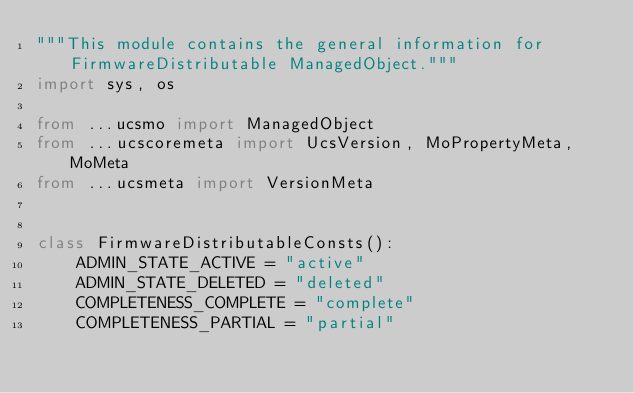<code> <loc_0><loc_0><loc_500><loc_500><_Python_>"""This module contains the general information for FirmwareDistributable ManagedObject."""
import sys, os

from ...ucsmo import ManagedObject
from ...ucscoremeta import UcsVersion, MoPropertyMeta, MoMeta
from ...ucsmeta import VersionMeta


class FirmwareDistributableConsts():
    ADMIN_STATE_ACTIVE = "active"
    ADMIN_STATE_DELETED = "deleted"
    COMPLETENESS_COMPLETE = "complete"
    COMPLETENESS_PARTIAL = "partial"</code> 